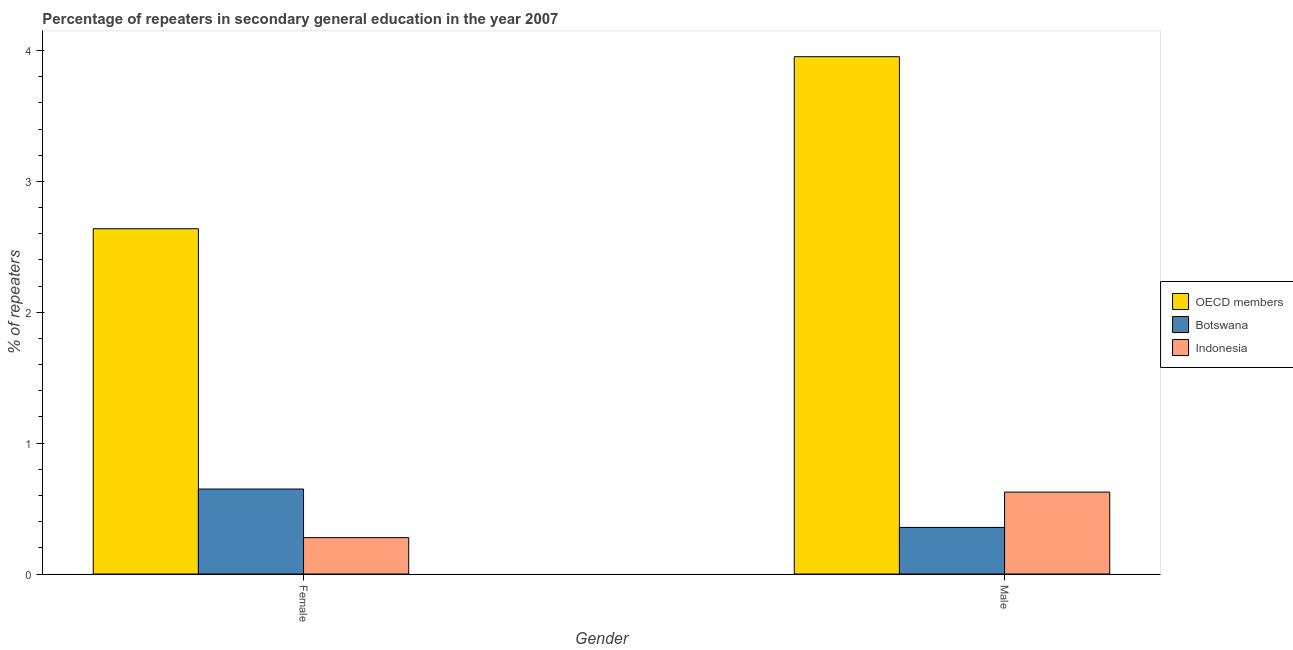How many groups of bars are there?
Your response must be concise. 2. Are the number of bars on each tick of the X-axis equal?
Keep it short and to the point. Yes. What is the percentage of female repeaters in Indonesia?
Keep it short and to the point. 0.28. Across all countries, what is the maximum percentage of male repeaters?
Give a very brief answer. 3.95. Across all countries, what is the minimum percentage of female repeaters?
Your response must be concise. 0.28. In which country was the percentage of female repeaters minimum?
Make the answer very short. Indonesia. What is the total percentage of male repeaters in the graph?
Your response must be concise. 4.94. What is the difference between the percentage of male repeaters in OECD members and that in Botswana?
Provide a succinct answer. 3.6. What is the difference between the percentage of male repeaters in Indonesia and the percentage of female repeaters in Botswana?
Your response must be concise. -0.02. What is the average percentage of male repeaters per country?
Your answer should be very brief. 1.65. What is the difference between the percentage of male repeaters and percentage of female repeaters in OECD members?
Offer a terse response. 1.31. What is the ratio of the percentage of male repeaters in Botswana to that in Indonesia?
Provide a short and direct response. 0.57. In how many countries, is the percentage of male repeaters greater than the average percentage of male repeaters taken over all countries?
Provide a succinct answer. 1. How many bars are there?
Provide a succinct answer. 6. What is the difference between two consecutive major ticks on the Y-axis?
Ensure brevity in your answer.  1. Where does the legend appear in the graph?
Give a very brief answer. Center right. How many legend labels are there?
Your answer should be compact. 3. How are the legend labels stacked?
Ensure brevity in your answer.  Vertical. What is the title of the graph?
Your answer should be very brief. Percentage of repeaters in secondary general education in the year 2007. Does "OECD members" appear as one of the legend labels in the graph?
Provide a short and direct response. Yes. What is the label or title of the Y-axis?
Provide a short and direct response. % of repeaters. What is the % of repeaters in OECD members in Female?
Offer a very short reply. 2.64. What is the % of repeaters in Botswana in Female?
Ensure brevity in your answer.  0.65. What is the % of repeaters in Indonesia in Female?
Offer a terse response. 0.28. What is the % of repeaters in OECD members in Male?
Your response must be concise. 3.95. What is the % of repeaters of Botswana in Male?
Give a very brief answer. 0.36. What is the % of repeaters of Indonesia in Male?
Make the answer very short. 0.63. Across all Gender, what is the maximum % of repeaters in OECD members?
Provide a succinct answer. 3.95. Across all Gender, what is the maximum % of repeaters of Botswana?
Your answer should be compact. 0.65. Across all Gender, what is the maximum % of repeaters of Indonesia?
Your answer should be very brief. 0.63. Across all Gender, what is the minimum % of repeaters of OECD members?
Keep it short and to the point. 2.64. Across all Gender, what is the minimum % of repeaters in Botswana?
Ensure brevity in your answer.  0.36. Across all Gender, what is the minimum % of repeaters in Indonesia?
Offer a very short reply. 0.28. What is the total % of repeaters in OECD members in the graph?
Make the answer very short. 6.59. What is the total % of repeaters of Botswana in the graph?
Your response must be concise. 1.01. What is the total % of repeaters of Indonesia in the graph?
Offer a very short reply. 0.9. What is the difference between the % of repeaters in OECD members in Female and that in Male?
Provide a succinct answer. -1.31. What is the difference between the % of repeaters in Botswana in Female and that in Male?
Your response must be concise. 0.29. What is the difference between the % of repeaters of Indonesia in Female and that in Male?
Ensure brevity in your answer.  -0.35. What is the difference between the % of repeaters of OECD members in Female and the % of repeaters of Botswana in Male?
Provide a short and direct response. 2.28. What is the difference between the % of repeaters of OECD members in Female and the % of repeaters of Indonesia in Male?
Your answer should be compact. 2.01. What is the difference between the % of repeaters in Botswana in Female and the % of repeaters in Indonesia in Male?
Keep it short and to the point. 0.02. What is the average % of repeaters of OECD members per Gender?
Your answer should be compact. 3.3. What is the average % of repeaters in Botswana per Gender?
Your response must be concise. 0.5. What is the average % of repeaters in Indonesia per Gender?
Your answer should be compact. 0.45. What is the difference between the % of repeaters in OECD members and % of repeaters in Botswana in Female?
Offer a terse response. 1.99. What is the difference between the % of repeaters in OECD members and % of repeaters in Indonesia in Female?
Give a very brief answer. 2.36. What is the difference between the % of repeaters of Botswana and % of repeaters of Indonesia in Female?
Make the answer very short. 0.37. What is the difference between the % of repeaters in OECD members and % of repeaters in Botswana in Male?
Make the answer very short. 3.6. What is the difference between the % of repeaters in OECD members and % of repeaters in Indonesia in Male?
Your answer should be very brief. 3.33. What is the difference between the % of repeaters in Botswana and % of repeaters in Indonesia in Male?
Your answer should be very brief. -0.27. What is the ratio of the % of repeaters in OECD members in Female to that in Male?
Ensure brevity in your answer.  0.67. What is the ratio of the % of repeaters in Botswana in Female to that in Male?
Keep it short and to the point. 1.82. What is the ratio of the % of repeaters in Indonesia in Female to that in Male?
Your response must be concise. 0.44. What is the difference between the highest and the second highest % of repeaters of OECD members?
Give a very brief answer. 1.31. What is the difference between the highest and the second highest % of repeaters of Botswana?
Ensure brevity in your answer.  0.29. What is the difference between the highest and the second highest % of repeaters of Indonesia?
Your answer should be very brief. 0.35. What is the difference between the highest and the lowest % of repeaters of OECD members?
Give a very brief answer. 1.31. What is the difference between the highest and the lowest % of repeaters in Botswana?
Your response must be concise. 0.29. What is the difference between the highest and the lowest % of repeaters of Indonesia?
Offer a terse response. 0.35. 